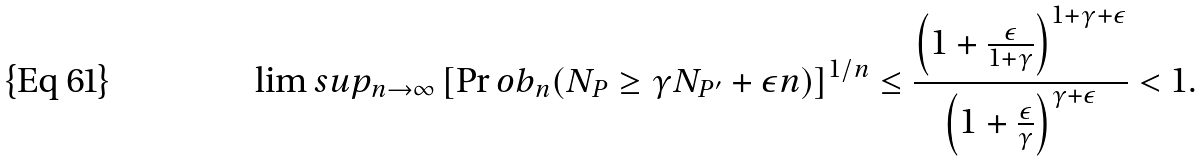<formula> <loc_0><loc_0><loc_500><loc_500>\lim s u p _ { n \to \infty } \left [ \Pr o b _ { n } ( N _ { P } \geq \gamma N _ { P ^ { \prime } } + \epsilon n ) \right ] ^ { 1 / n } \leq \frac { \left ( 1 + \frac { \epsilon } { 1 + \gamma } \right ) ^ { 1 + \gamma + \epsilon } } { \left ( 1 + \frac { \epsilon } { \gamma } \right ) ^ { \gamma + \epsilon } } < 1 .</formula> 